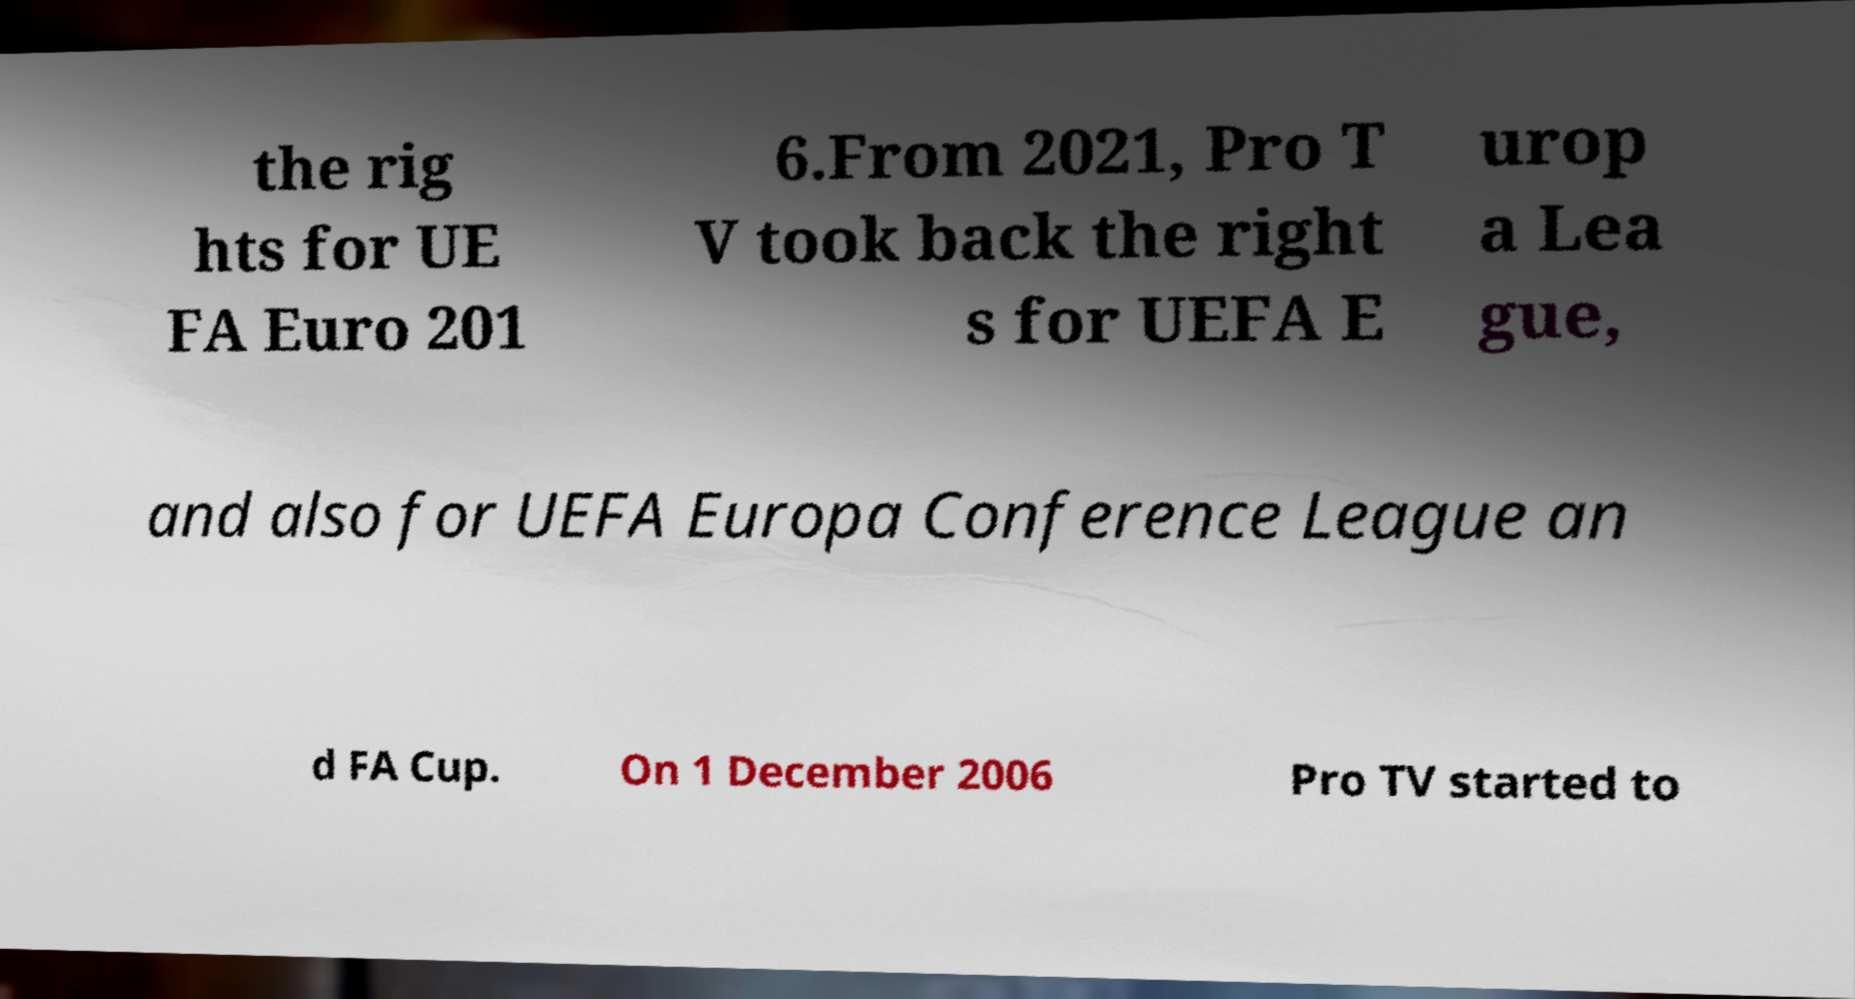Could you assist in decoding the text presented in this image and type it out clearly? the rig hts for UE FA Euro 201 6.From 2021, Pro T V took back the right s for UEFA E urop a Lea gue, and also for UEFA Europa Conference League an d FA Cup. On 1 December 2006 Pro TV started to 